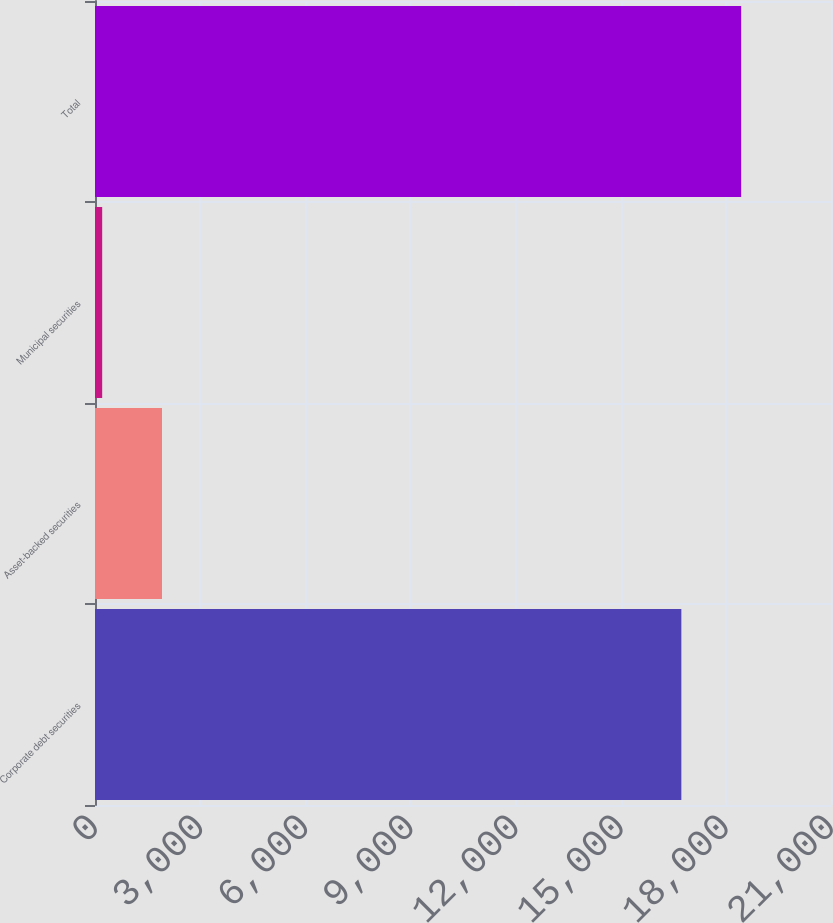Convert chart to OTSL. <chart><loc_0><loc_0><loc_500><loc_500><bar_chart><fcel>Corporate debt securities<fcel>Asset-backed securities<fcel>Municipal securities<fcel>Total<nl><fcel>16730<fcel>1911.7<fcel>205<fcel>18436.7<nl></chart> 